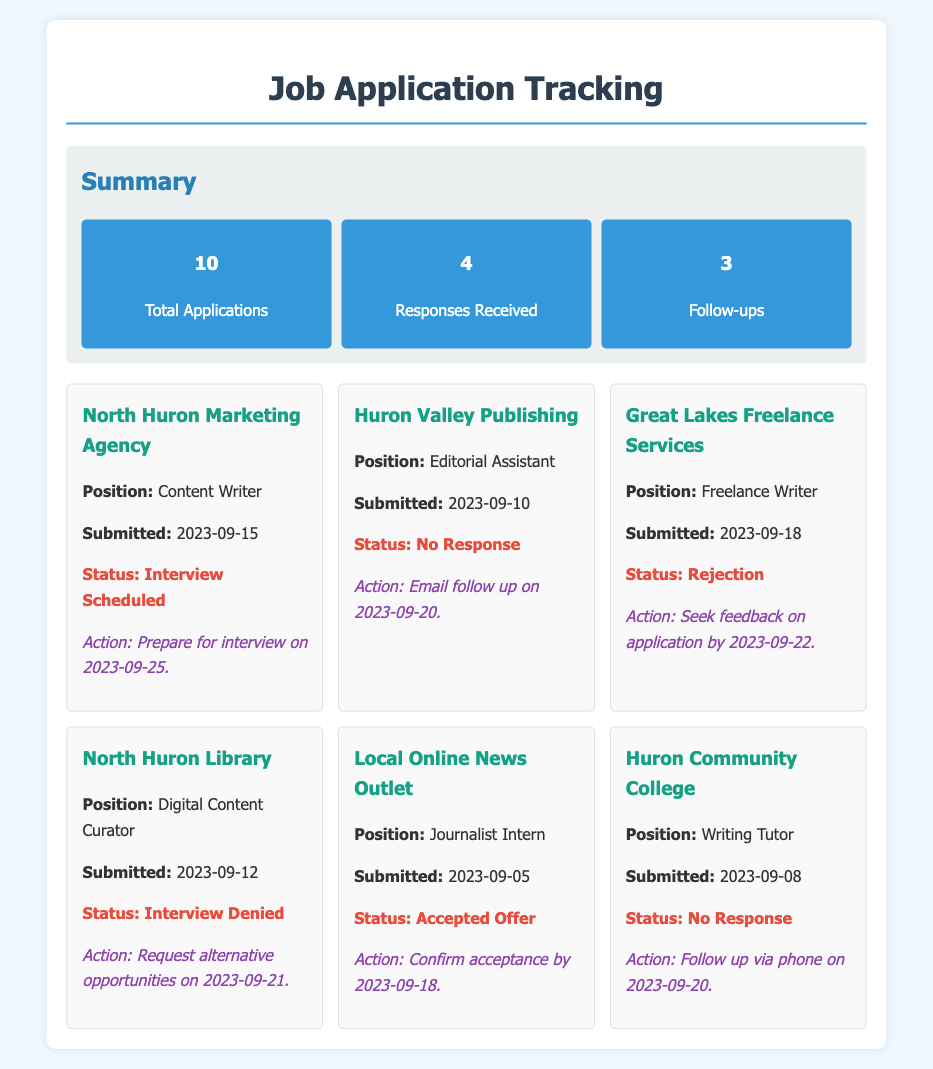What is the total number of applications submitted? The total number of applications is listed in the summary section as "10."
Answer: 10 How many responses were received? The number of responses received is noted in the summary as "4."
Answer: 4 Which position had an interview scheduled? The document states that the "Content Writer" position has an "Interview Scheduled."
Answer: Content Writer What was the status of the application to Great Lakes Freelance Services? The status for Great Lakes Freelance Services is indicated as "Rejection."
Answer: Rejection What is the deadline to confirm acceptance for the Journalist Intern position? The document specifies that the action is to "Confirm acceptance by 2023-09-18."
Answer: 2023-09-18 How many follow-ups were noted in the document? The summary section states that there were "3" follow-ups.
Answer: 3 What action is suggested for the Huron Valley Publishing application? The follow-up action for the Huron Valley Publishing application is to "Email follow up on 2023-09-20."
Answer: Email follow up on 2023-09-20 Which agency had a position for a Digital Content Curator? The agency listed for the Digital Content Curator position is the "North Huron Library."
Answer: North Huron Library What was the submission date for the Freelance Writer position? The Freelance Writer position submission date is noted as "2023-09-18."
Answer: 2023-09-18 